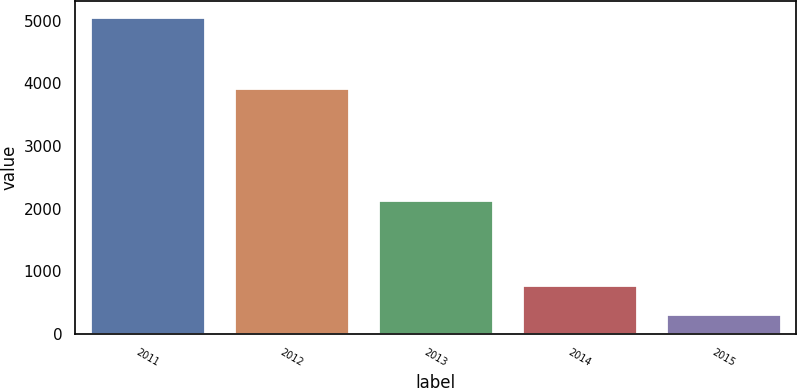Convert chart to OTSL. <chart><loc_0><loc_0><loc_500><loc_500><bar_chart><fcel>2011<fcel>2012<fcel>2013<fcel>2014<fcel>2015<nl><fcel>5061<fcel>3929<fcel>2133<fcel>789.6<fcel>315<nl></chart> 